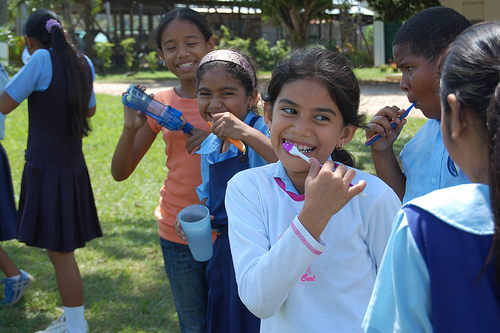What is the pink clothing item? The pink item is a casual shirt, worn by the girl who is busy brushing her teeth, blending nicely with her playful and cheerful attire. 